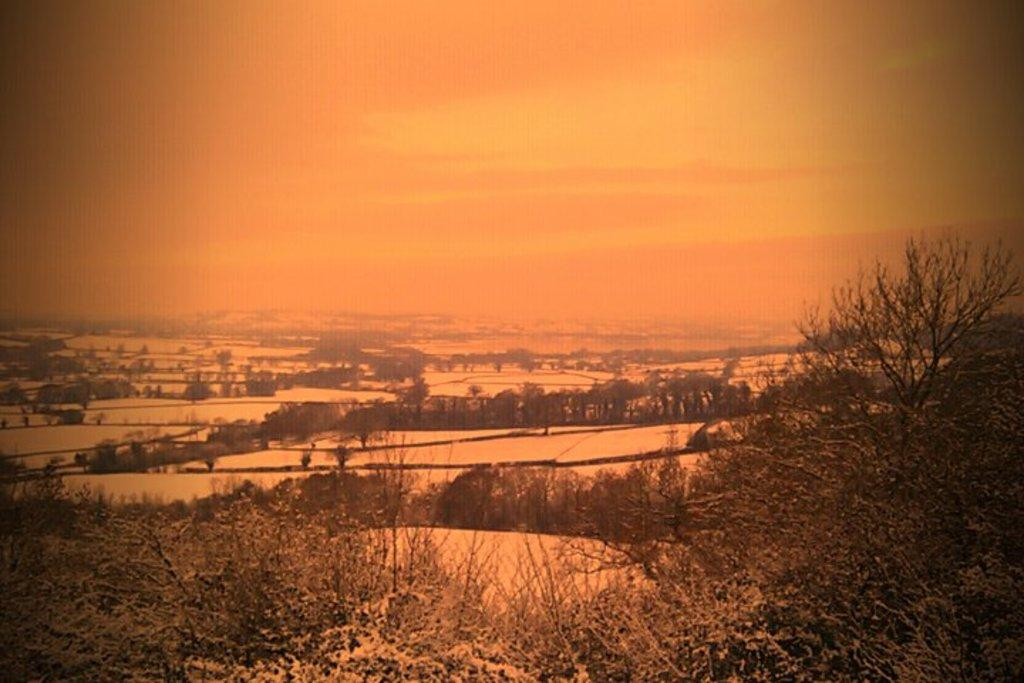What is located at the left bottom of the image? There are plants at the left bottom of the image. What can be seen in the background of the image? There are trees in the background of the image. What is visible at the top of the image? The sky is visible at the top of the image. How many seats can be seen in the image? There are no seats present in the image. What type of mist is visible in the image? There is no mist visible in the image; it features plants, trees, and the sky. 